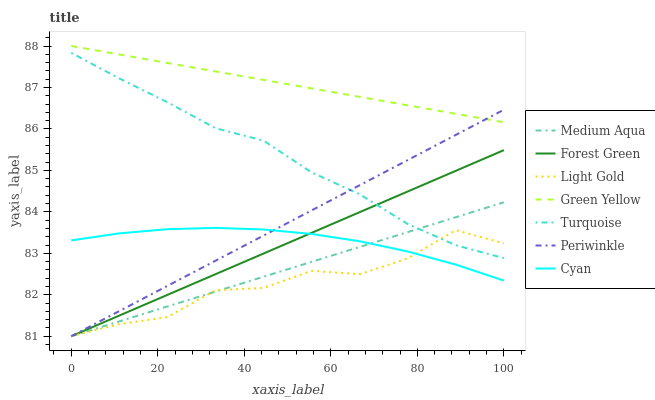Does Light Gold have the minimum area under the curve?
Answer yes or no. Yes. Does Green Yellow have the maximum area under the curve?
Answer yes or no. Yes. Does Forest Green have the minimum area under the curve?
Answer yes or no. No. Does Forest Green have the maximum area under the curve?
Answer yes or no. No. Is Periwinkle the smoothest?
Answer yes or no. Yes. Is Light Gold the roughest?
Answer yes or no. Yes. Is Forest Green the smoothest?
Answer yes or no. No. Is Forest Green the roughest?
Answer yes or no. No. Does Forest Green have the lowest value?
Answer yes or no. Yes. Does Cyan have the lowest value?
Answer yes or no. No. Does Green Yellow have the highest value?
Answer yes or no. Yes. Does Forest Green have the highest value?
Answer yes or no. No. Is Forest Green less than Green Yellow?
Answer yes or no. Yes. Is Green Yellow greater than Turquoise?
Answer yes or no. Yes. Does Light Gold intersect Cyan?
Answer yes or no. Yes. Is Light Gold less than Cyan?
Answer yes or no. No. Is Light Gold greater than Cyan?
Answer yes or no. No. Does Forest Green intersect Green Yellow?
Answer yes or no. No. 